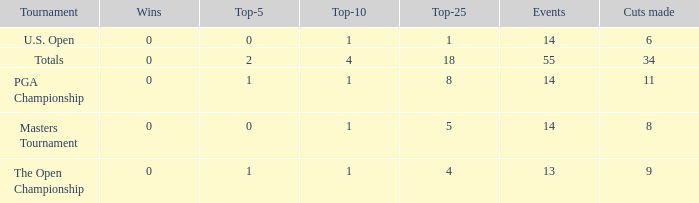What is the average top-10 when the cuts made is less than 9 and the events is more than 14? None. 